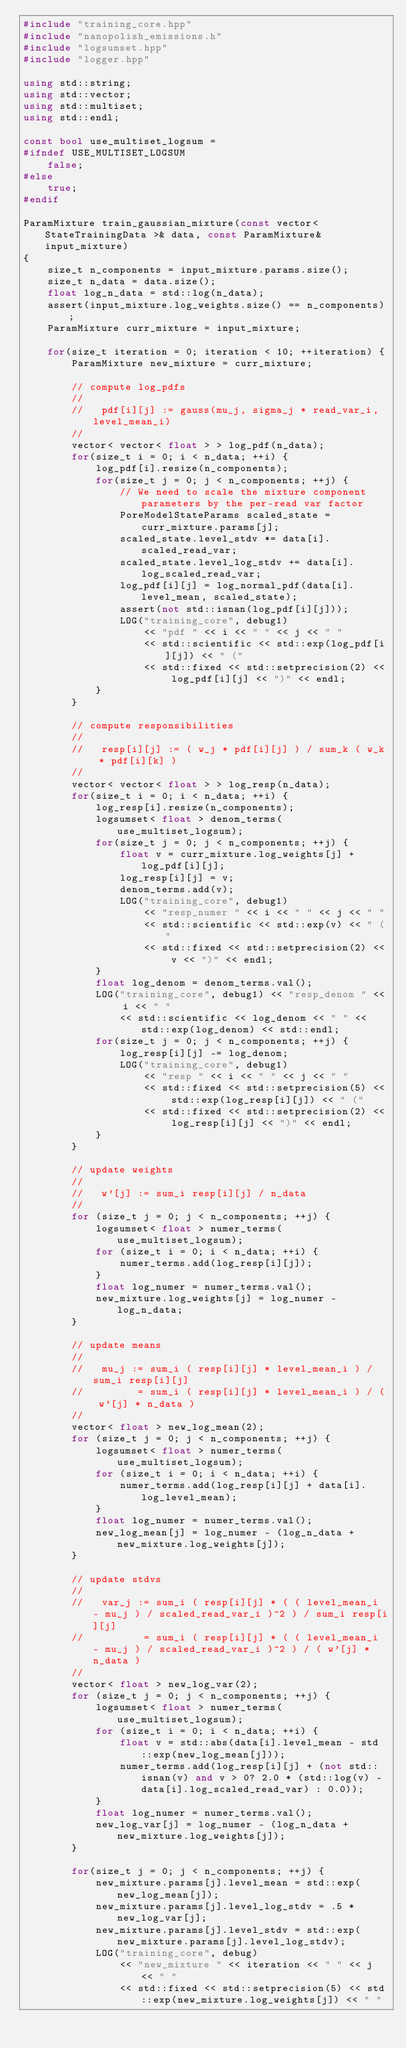Convert code to text. <code><loc_0><loc_0><loc_500><loc_500><_C++_>#include "training_core.hpp"
#include "nanopolish_emissions.h"
#include "logsumset.hpp"
#include "logger.hpp"

using std::string;
using std::vector;
using std::multiset;
using std::endl;

const bool use_multiset_logsum = 
#ifndef USE_MULTISET_LOGSUM
    false;
#else
    true;
#endif

ParamMixture train_gaussian_mixture(const vector< StateTrainingData >& data, const ParamMixture& input_mixture)
{
    size_t n_components = input_mixture.params.size();
    size_t n_data = data.size();
    float log_n_data = std::log(n_data);
    assert(input_mixture.log_weights.size() == n_components);
    ParamMixture curr_mixture = input_mixture;

    for(size_t iteration = 0; iteration < 10; ++iteration) {
        ParamMixture new_mixture = curr_mixture;

        // compute log_pdfs
        //
        //   pdf[i][j] := gauss(mu_j, sigma_j * read_var_i, level_mean_i)
        //
        vector< vector< float > > log_pdf(n_data);
        for(size_t i = 0; i < n_data; ++i) {
            log_pdf[i].resize(n_components);
            for(size_t j = 0; j < n_components; ++j) {
                // We need to scale the mixture component parameters by the per-read var factor
                PoreModelStateParams scaled_state = curr_mixture.params[j];
                scaled_state.level_stdv *= data[i].scaled_read_var;
                scaled_state.level_log_stdv += data[i].log_scaled_read_var;
                log_pdf[i][j] = log_normal_pdf(data[i].level_mean, scaled_state);
                assert(not std::isnan(log_pdf[i][j]));
                LOG("training_core", debug1)
                    << "pdf " << i << " " << j << " "
                    << std::scientific << std::exp(log_pdf[i][j]) << " ("
                    << std::fixed << std::setprecision(2) << log_pdf[i][j] << ")" << endl;
            }
        }

        // compute responsibilities
        //
        //   resp[i][j] := ( w_j * pdf[i][j] ) / sum_k ( w_k * pdf[i][k] )
        //
        vector< vector< float > > log_resp(n_data);
        for(size_t i = 0; i < n_data; ++i) {
            log_resp[i].resize(n_components);
            logsumset< float > denom_terms(use_multiset_logsum);
            for(size_t j = 0; j < n_components; ++j) {
                float v = curr_mixture.log_weights[j] + log_pdf[i][j];
                log_resp[i][j] = v;
                denom_terms.add(v);
                LOG("training_core", debug1)
                    << "resp_numer " << i << " " << j << " "
                    << std::scientific << std::exp(v) << " ("
                    << std::fixed << std::setprecision(2) << v << ")" << endl;
            }
            float log_denom = denom_terms.val();
            LOG("training_core", debug1) << "resp_denom " << i << " "
                << std::scientific << log_denom << " " << std::exp(log_denom) << std::endl;
            for(size_t j = 0; j < n_components; ++j) {
                log_resp[i][j] -= log_denom;
                LOG("training_core", debug1)
                    << "resp " << i << " " << j << " "
                    << std::fixed << std::setprecision(5) << std::exp(log_resp[i][j]) << " ("
                    << std::fixed << std::setprecision(2) << log_resp[i][j] << ")" << endl;
            }
        }

        // update weights
        //
        //   w'[j] := sum_i resp[i][j] / n_data
        //
        for (size_t j = 0; j < n_components; ++j) {
            logsumset< float > numer_terms(use_multiset_logsum);
            for (size_t i = 0; i < n_data; ++i) {
                numer_terms.add(log_resp[i][j]);
            }
            float log_numer = numer_terms.val();
            new_mixture.log_weights[j] = log_numer - log_n_data;
        }

        // update means
        //
        //   mu_j := sum_i ( resp[i][j] * level_mean_i ) / sum_i resp[i][j]
        //         = sum_i ( resp[i][j] * level_mean_i ) / ( w'[j] * n_data )
        //
        vector< float > new_log_mean(2);
        for (size_t j = 0; j < n_components; ++j) {
            logsumset< float > numer_terms(use_multiset_logsum);
            for (size_t i = 0; i < n_data; ++i) {
                numer_terms.add(log_resp[i][j] + data[i].log_level_mean);
            }
            float log_numer = numer_terms.val();
            new_log_mean[j] = log_numer - (log_n_data + new_mixture.log_weights[j]);
        }

        // update stdvs
        //
        //   var_j := sum_i ( resp[i][j] * ( ( level_mean_i - mu_j ) / scaled_read_var_i )^2 ) / sum_i resp[i][j]
        //          = sum_i ( resp[i][j] * ( ( level_mean_i - mu_j ) / scaled_read_var_i )^2 ) / ( w'[j] * n_data )
        //
        vector< float > new_log_var(2);
        for (size_t j = 0; j < n_components; ++j) {
            logsumset< float > numer_terms(use_multiset_logsum);
            for (size_t i = 0; i < n_data; ++i) {
                float v = std::abs(data[i].level_mean - std::exp(new_log_mean[j]));
                numer_terms.add(log_resp[i][j] + (not std::isnan(v) and v > 0? 2.0 * (std::log(v) - data[i].log_scaled_read_var) : 0.0));
            }
            float log_numer = numer_terms.val();
            new_log_var[j] = log_numer - (log_n_data + new_mixture.log_weights[j]);
        }

        for(size_t j = 0; j < n_components; ++j) {
            new_mixture.params[j].level_mean = std::exp(new_log_mean[j]);
            new_mixture.params[j].level_log_stdv = .5 * new_log_var[j];
            new_mixture.params[j].level_stdv = std::exp(new_mixture.params[j].level_log_stdv);
            LOG("training_core", debug)
                << "new_mixture " << iteration << " " << j << " "
                << std::fixed << std::setprecision(5) << std::exp(new_mixture.log_weights[j]) << " "</code> 